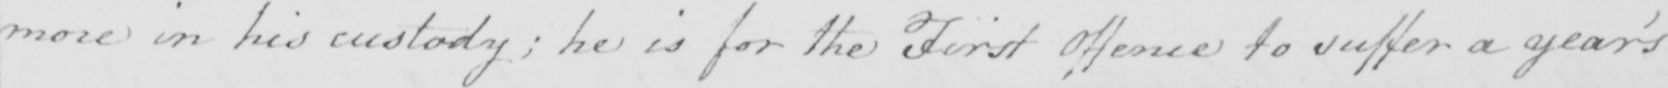What does this handwritten line say? more in his custody ; he is for the First Offence to suffer a year ' s 